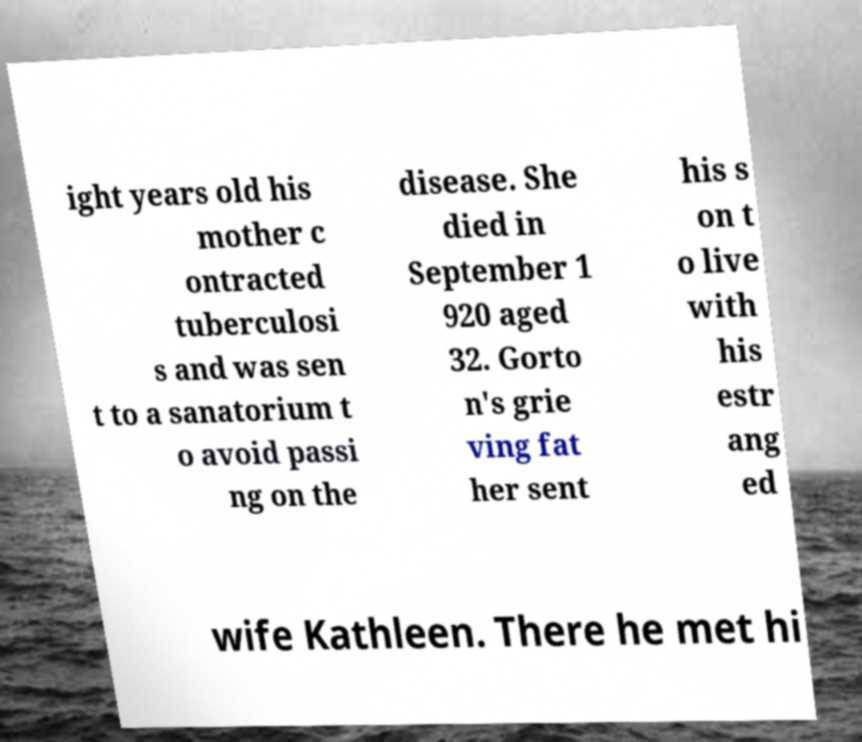For documentation purposes, I need the text within this image transcribed. Could you provide that? ight years old his mother c ontracted tuberculosi s and was sen t to a sanatorium t o avoid passi ng on the disease. She died in September 1 920 aged 32. Gorto n's grie ving fat her sent his s on t o live with his estr ang ed wife Kathleen. There he met hi 